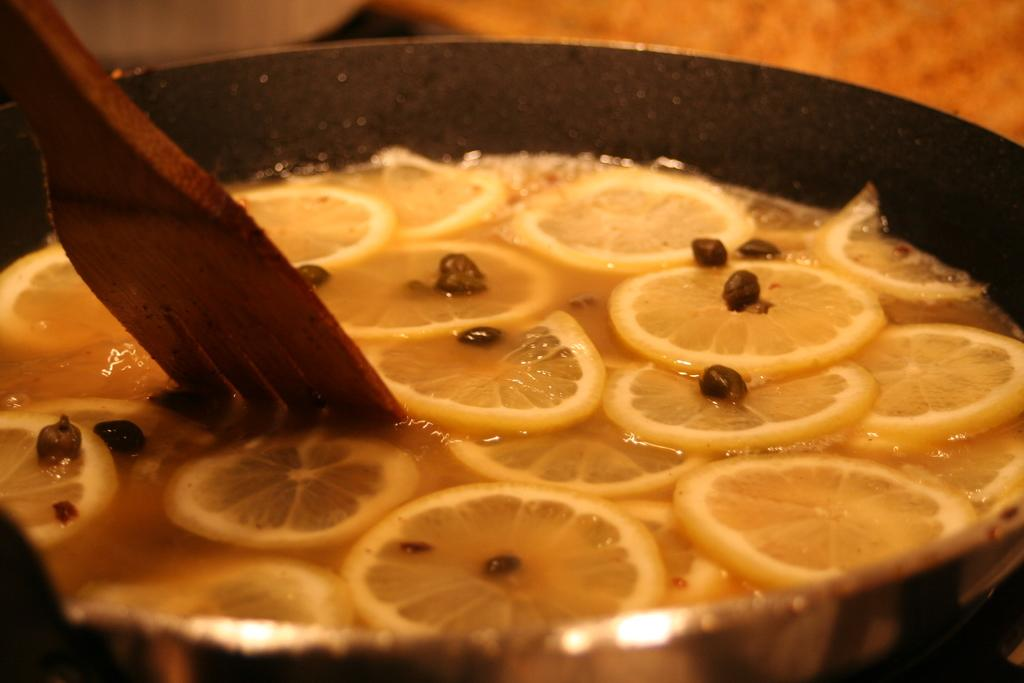What is in the pan that is visible in the image? There is a pan containing food in the image. What utensil is present in the image? There is a wooden spoon in the image. How would you describe the background color of the image? The background of the image is light brown and white in color. Can you tell me how many silk scarves are draped over the pan in the image? There are no silk scarves present in the image; it features a pan containing food and a wooden spoon. 